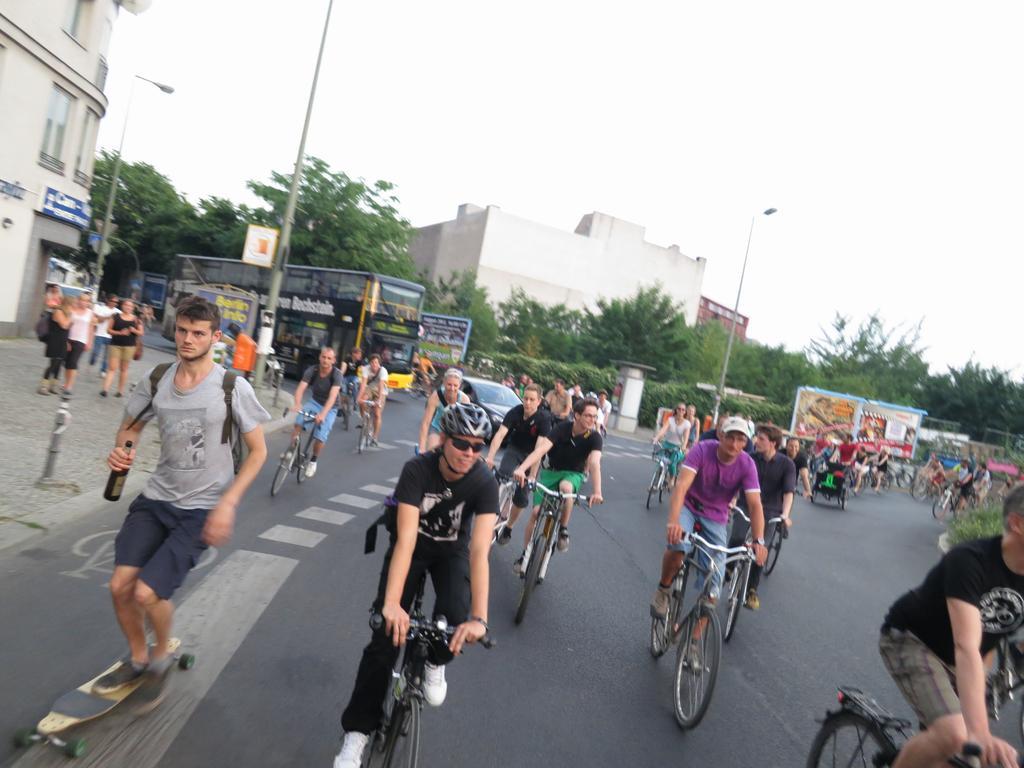Could you give a brief overview of what you see in this image? This is a picture taken in the outdoors. It is sunny. There are group of people riding the bicycle on road. The man riding a skateboard and holding a bottle. Background of this people is a pole, tree, building and sky. 